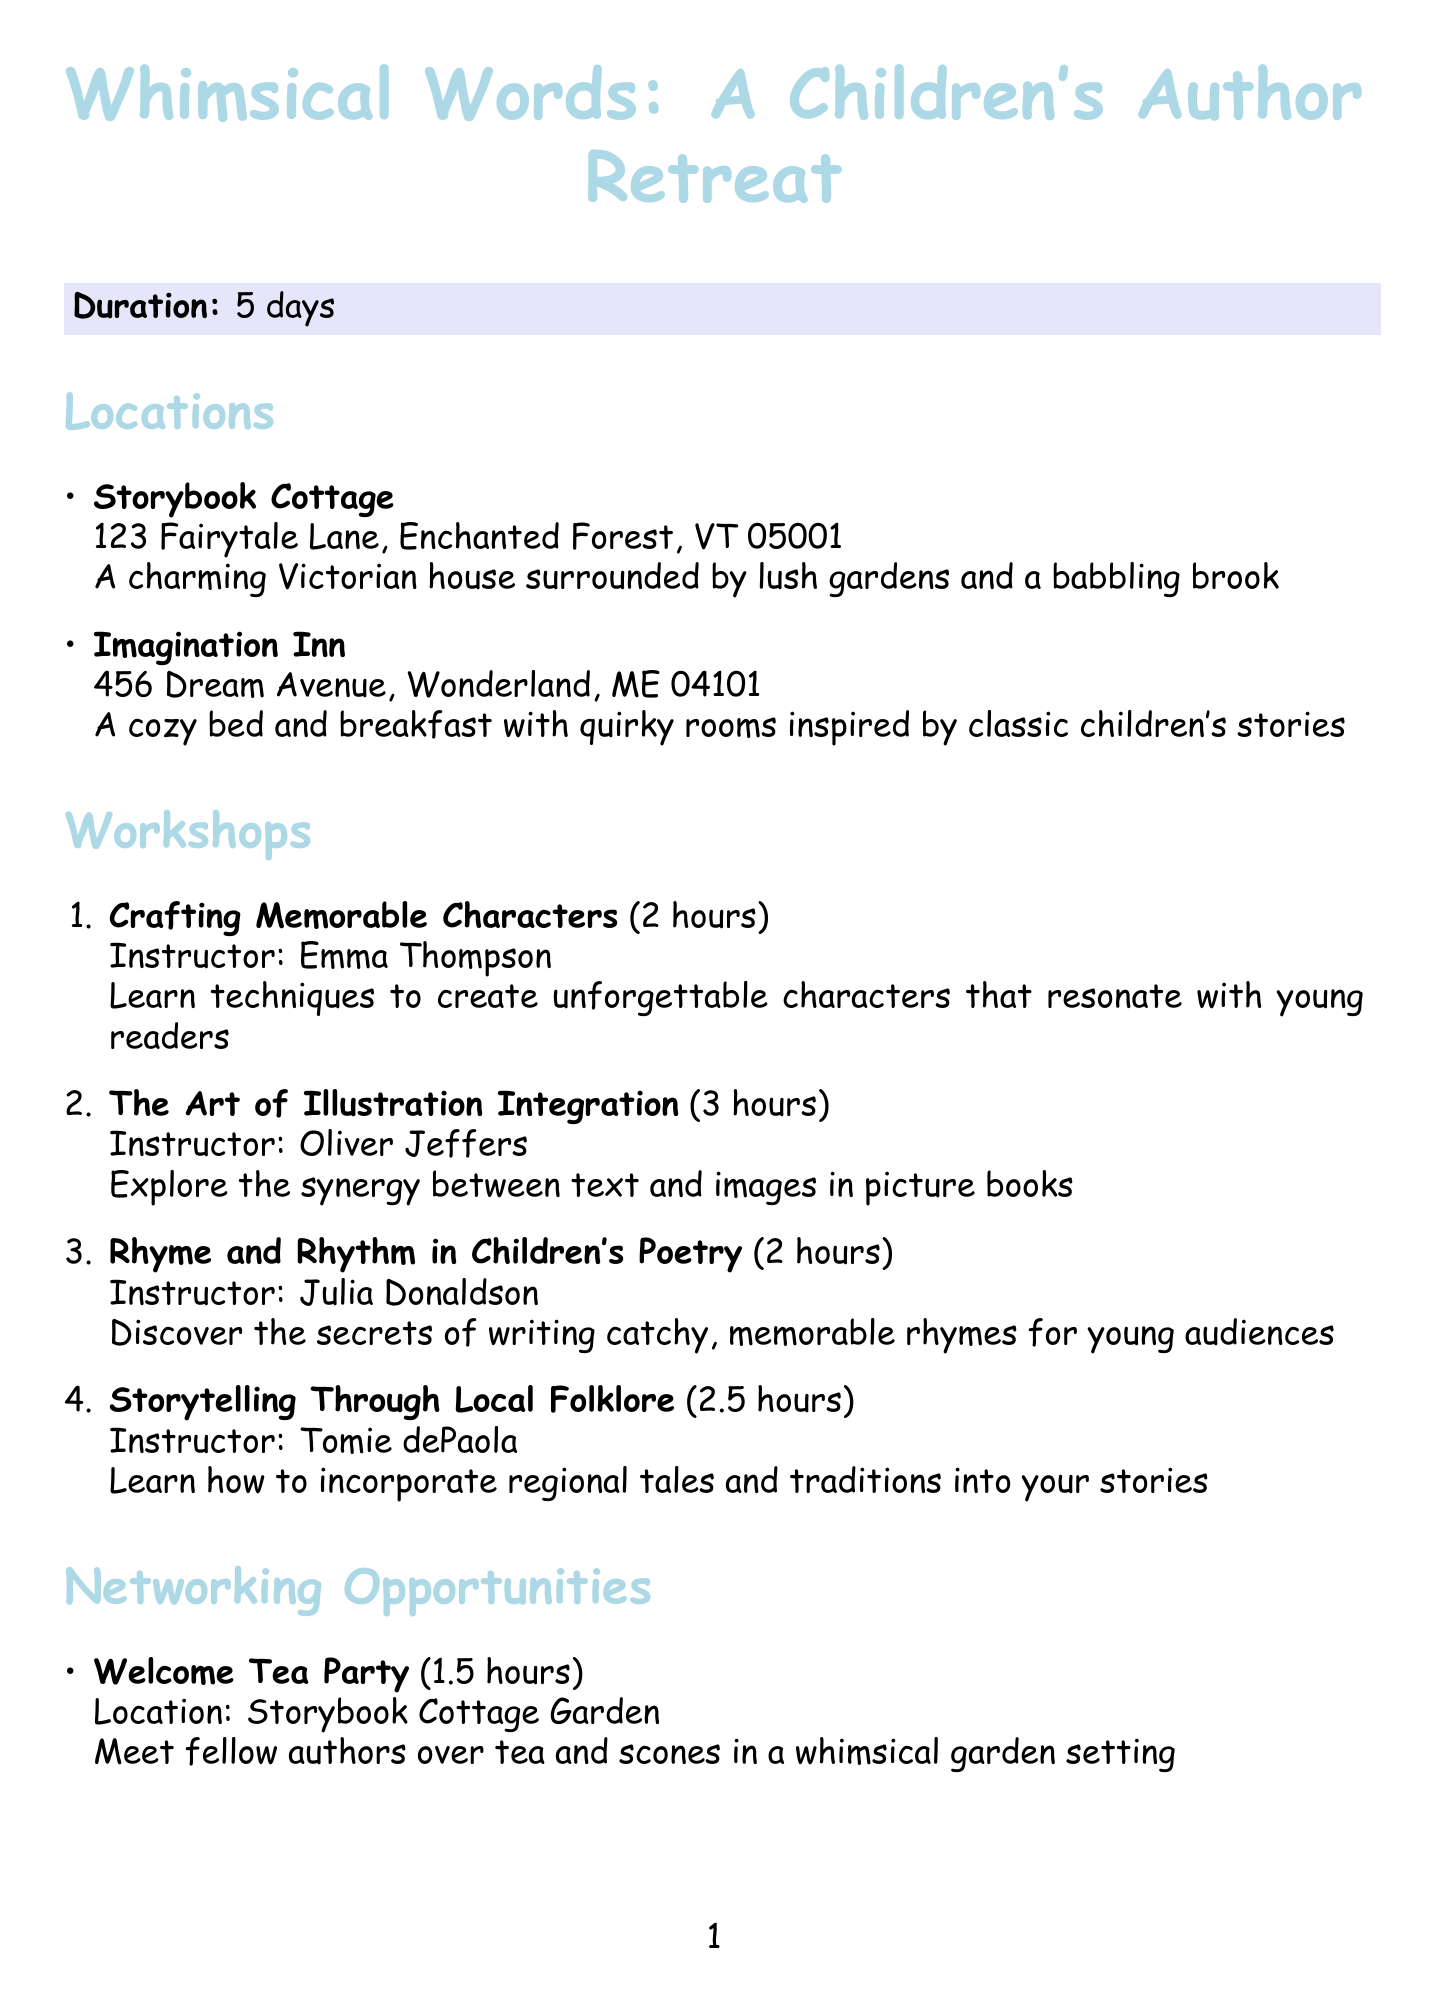what is the name of the retreat? The name of the retreat is provided at the beginning of the document.
Answer: Whimsical Words: A Children's Author Retreat how many days does the retreat last? The duration of the retreat is stated in the document.
Answer: 5 days who is the instructor for the workshop on character crafting? The document lists the instructors for each workshop, including the one on character crafting.
Answer: Emma Thompson what is the location of the Welcome Tea Party? The document specifies where each networking opportunity takes place, including the Welcome Tea Party.
Answer: Storybook Cottage Garden how long is the workshop on the Art of Illustration Integration? The duration of each workshop is detailed in the document.
Answer: 3 hours which special event involves reading to children? The document describes various special events and identifies the one related to reading to children.
Answer: Story Time at the Local Library how many workshops are there in total? By counting the workshops listed in the document, one can determine the total number.
Answer: 4 what type of event is the Costume Dinner? The nature of each networking opportunity or event is described in the document, including the Costume Dinner.
Answer: Networking opportunity what is the address of the Imagination Inn? The address for each location is provided in the document.
Answer: 456 Dream Avenue, Wonderland, ME 04101 